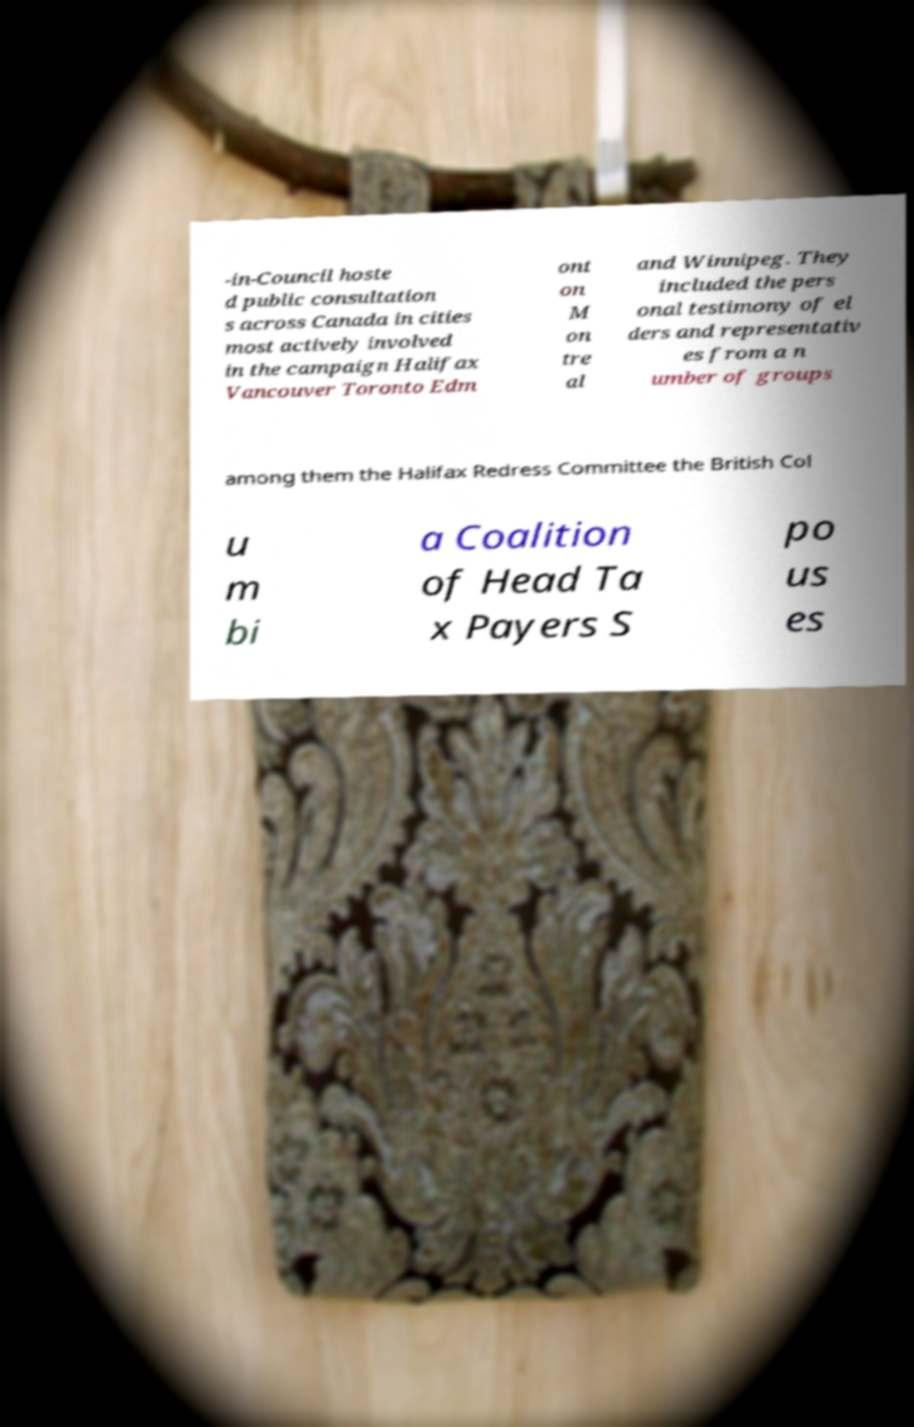Can you read and provide the text displayed in the image?This photo seems to have some interesting text. Can you extract and type it out for me? -in-Council hoste d public consultation s across Canada in cities most actively involved in the campaign Halifax Vancouver Toronto Edm ont on M on tre al and Winnipeg. They included the pers onal testimony of el ders and representativ es from a n umber of groups among them the Halifax Redress Committee the British Col u m bi a Coalition of Head Ta x Payers S po us es 